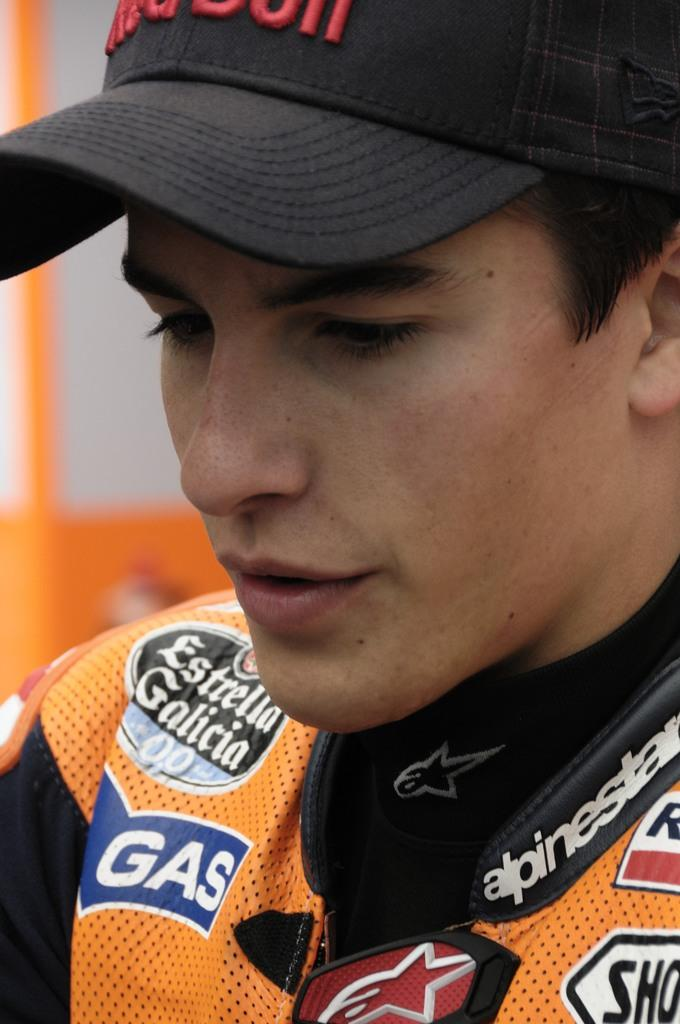<image>
Summarize the visual content of the image. A man is wearing a shirt that has the word gas on it. 